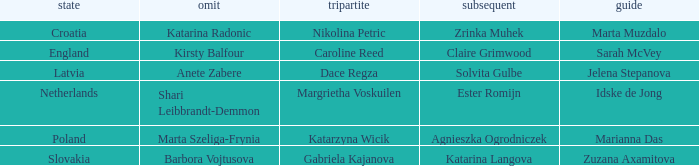Which Lead has Katarina Radonic as Skip? Marta Muzdalo. 